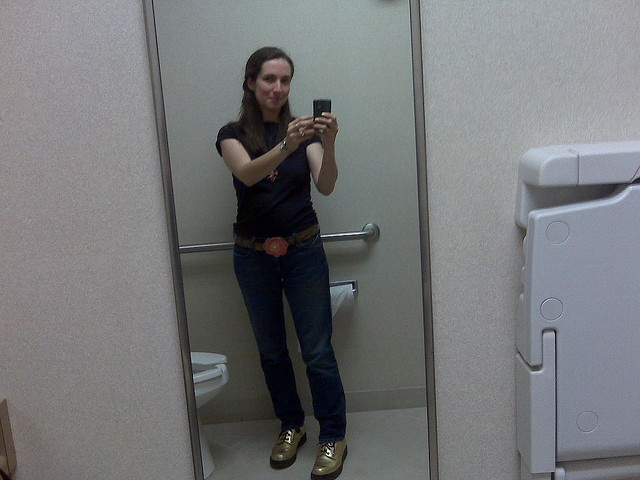Describe the objects in this image and their specific colors. I can see people in gray and black tones, toilet in gray tones, and cell phone in gray, black, and purple tones in this image. 